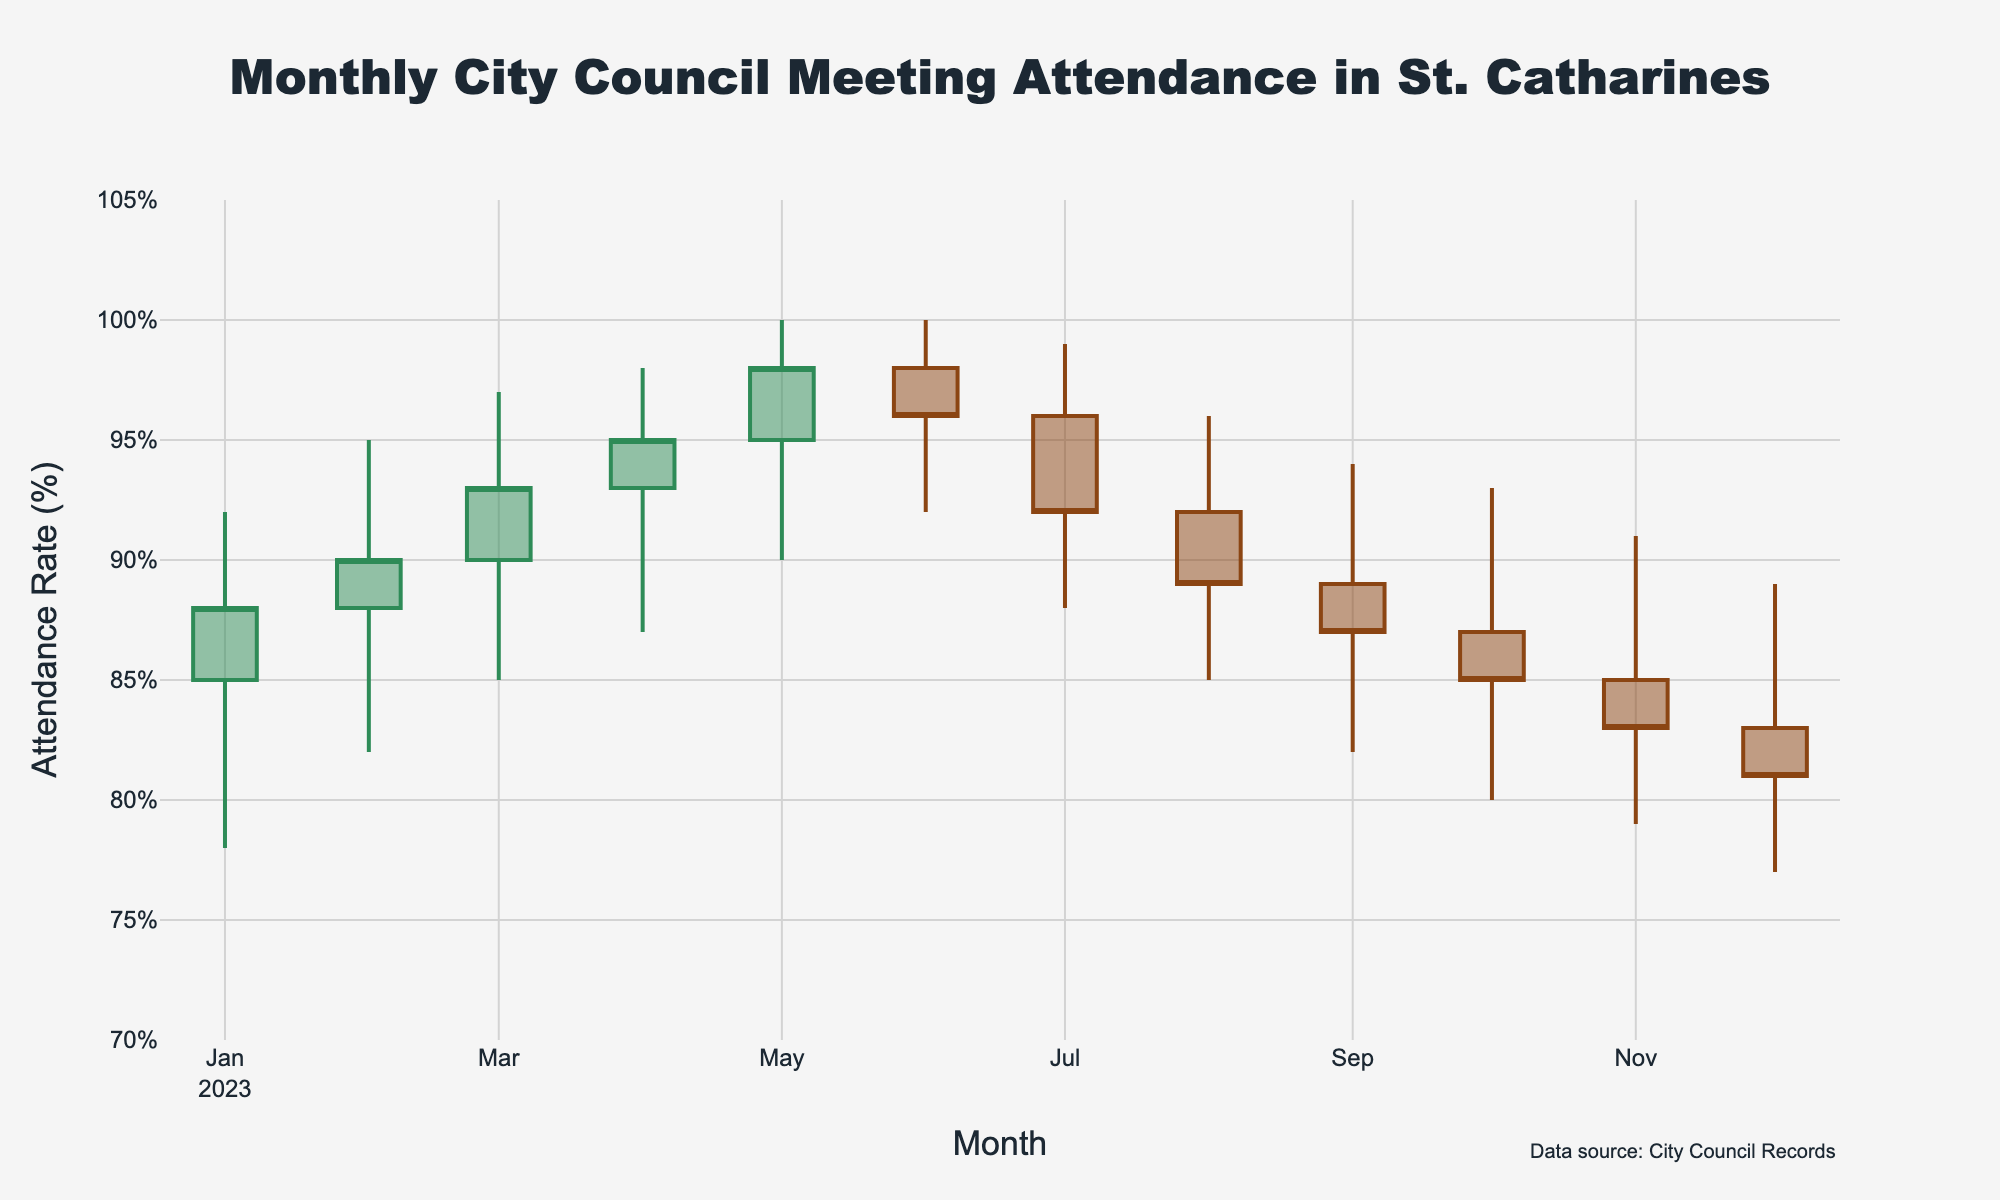How many months are represented in the chart? There are 12 months represented in the chart, starting from January 2023 to December 2023, as indicated on the x-axis.
Answer: 12 What is the highest attendance rate recorded, and in which month did it occur? The highest attendance rate recorded is 100%, which occurred in both May 2023 and June 2023, as shown by the highest points in those months.
Answer: 100%, May and June 2023 How does the closing attendance rate in July 2023 compare to the closing attendance rate in August 2023? The closing attendance rate in July 2023 is 92%, while it is 89% in August 2023. To compare, 92% is higher than 89%.
Answer: July 2023 is higher What is the average low attendance rate for the first half of the year (January–June)? The low attendance rates from January to June are 78, 82, 85, 87, 90, and 92 respectively. Adding these gives 514, and dividing by 6 gives an average of 85.67%.
Answer: 85.67% Which month showed the greatest difference between the high and low attendance rates? To find this, calculate the difference between high and low attendance rates for each month. The greatest difference occurs in February 2023 with 95% (high) - 82% (low) = 13%.
Answer: February 2023 In which month did the attendance start highest, and how much was it? The month with the highest opening attendance rate is June 2023, starting at 98%.
Answer: June 2023, 98% What trend can you observe from the attendance rates from January 2023 to December 2023? Observing the chart, there is an increasing trend in attendance rates from January to May 2023, followed by fluctuating rates from June to December 2023, with a general decline toward the end of the year.
Answer: Increasing then declining What is the median closing attendance rate for all the months represented? Listing the closing attendance rates from lowest to highest: 81, 83, 85, 87, 88, 89, 90, 92, 93, 95, 96, 98. The median is the average of the 6th and 7th values: (89 + 90) / 2 = 89.5%.
Answer: 89.5% 